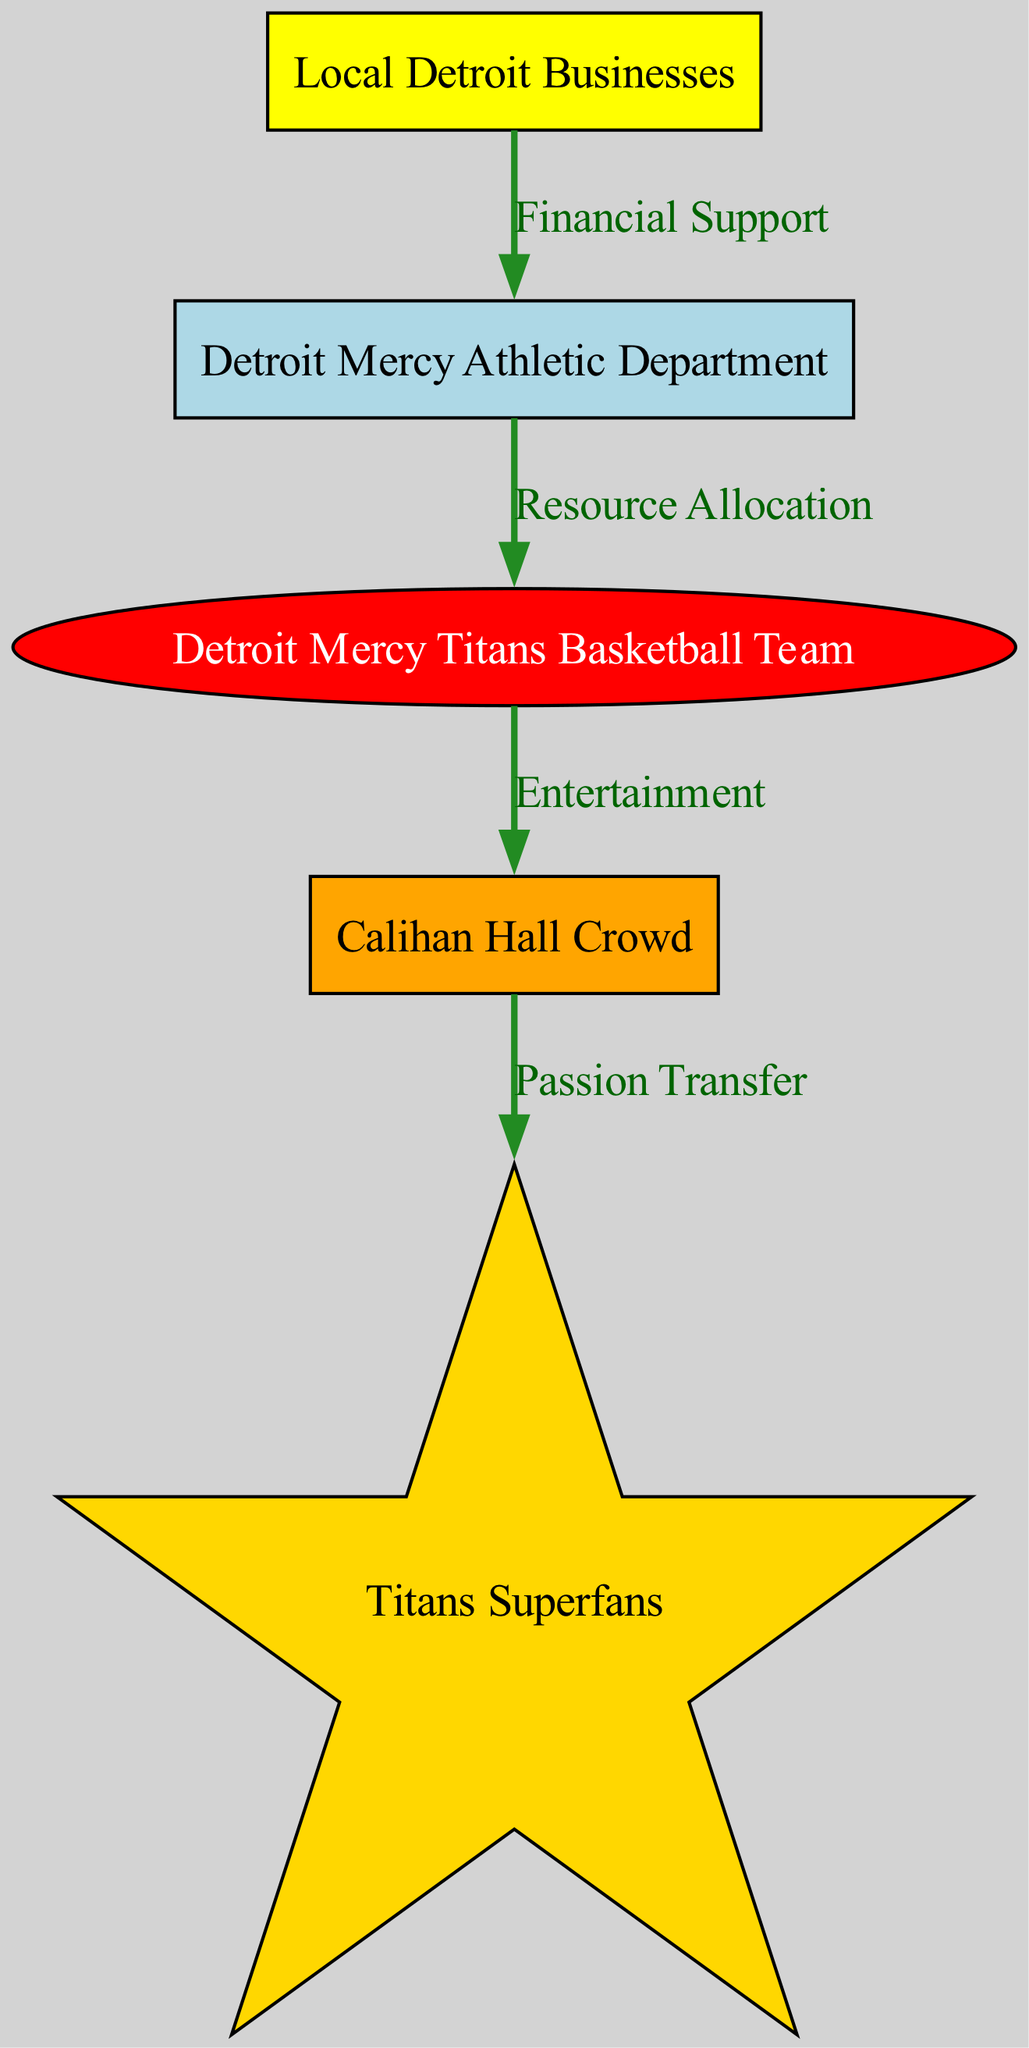What is the first trophic level in the food chain? The diagram identifies "Local Detroit Businesses" as the first element with level 1, indicating its role as the initial source of support in the food chain for the Titans.
Answer: Local Detroit Businesses How many trophic levels are represented in the diagram? The diagram features five distinct levels, each representing a different category of participants or supporters in the sports sponsorship food chain.
Answer: Five What type of relationship exists between the Detroit Mercy Athletic Department and the Detroit Mercy Titans Basketball Team? The relationship is depicted as "Resource Allocation," highlighting the supportive role of the Athletic Department in providing necessary resources to the basketball team.
Answer: Resource Allocation Which group is classified as the tertiary consumer in the food chain? The diagram specifies "Titans Superfans" as the tertiary consumer, highlighting their position as avid supporters and enthusiasts of the team after the primary and secondary consumers.
Answer: Titans Superfans What does the edge between the primary consumer and the secondary consumer represent? The edge labeled "Entertainment" illustrates the flow of entertainment from the basketball team to the crowd, emphasizing the engagement the team provides during games.
Answer: Entertainment Which node directly receives financial support? The "Detroit Mercy Athletic Department" is the node that directly receives financial support from local Detroit businesses, establishing its foundation for further allocations.
Answer: Detroit Mercy Athletic Department What is the nature of the connection between the Calihan Hall Crowd and the Titans Superfans? The diagram indicates a connection termed "Passion Transfer," showcasing how the enthusiasm of the crowd influences the Titans Superfans, creating a deeper connection and engagement.
Answer: Passion Transfer How does the food chain demonstrate a customer relationship model? The diagram illustrates the hierarchical relationships and support system between different levels, portraying how local businesses, the Athletic Department, the basketball team, and the fans collectively contribute to and benefit from each other in the sports sponsorship ecosystem.
Answer: Hierarchical relationships What element is considered the "producer" in this food chain? The diagram defines the "Detroit Mercy Athletic Department" as the producer, highlighting its role in producing resources and opportunities for the basketball team.
Answer: Detroit Mercy Athletic Department 